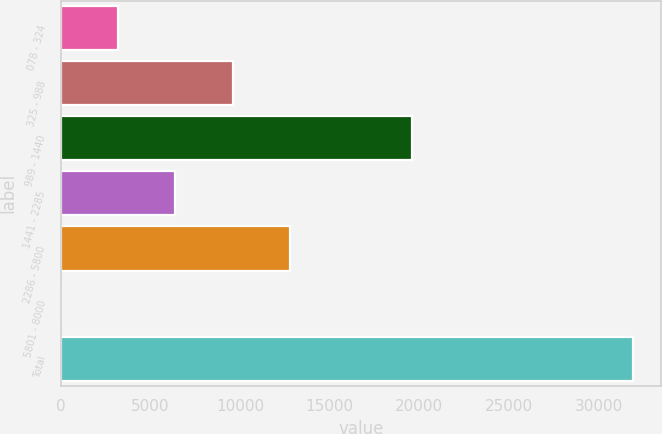Convert chart. <chart><loc_0><loc_0><loc_500><loc_500><bar_chart><fcel>078 - 324<fcel>325 - 988<fcel>989 - 1440<fcel>1441 - 2285<fcel>2286 - 5800<fcel>5801 - 8000<fcel>Total<nl><fcel>3198.4<fcel>9577.2<fcel>19580<fcel>6387.8<fcel>12766.6<fcel>9<fcel>31903<nl></chart> 